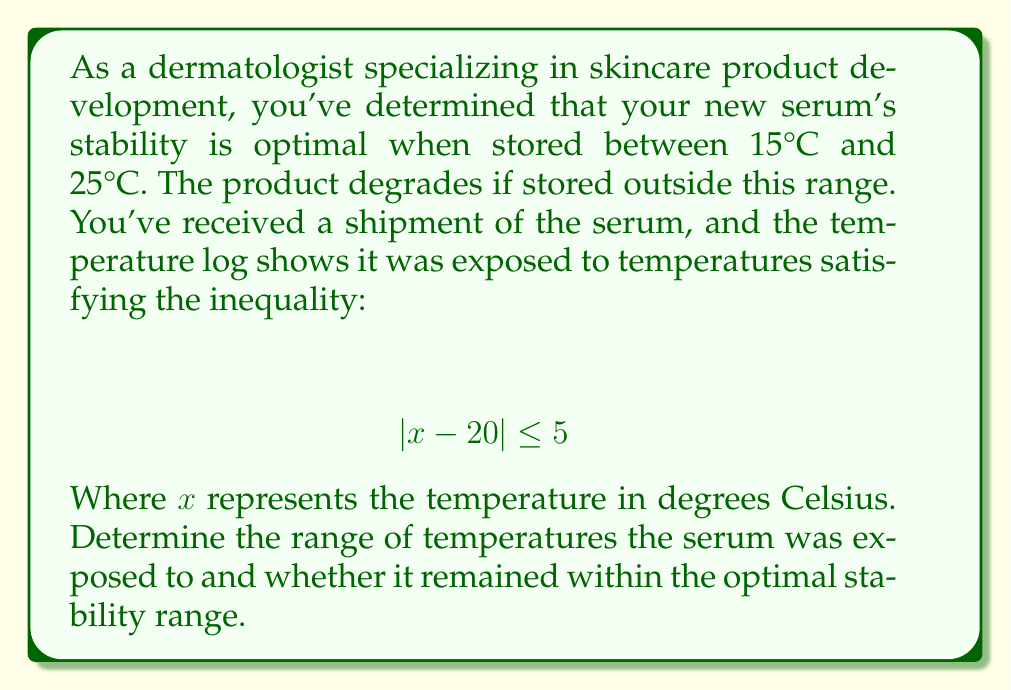Can you solve this math problem? Let's approach this step-by-step:

1) The inequality $|x - 20| \leq 5$ can be interpreted as the absolute difference between $x$ and 20 being less than or equal to 5.

2) To solve this, we can split it into two parts:
   $$ -5 \leq x - 20 \leq 5 $$

3) Add 20 to all parts of the inequality:
   $$ -5 + 20 \leq x - 20 + 20 \leq 5 + 20 $$
   $$ 15 \leq x \leq 25 $$

4) This means the serum was exposed to temperatures between 15°C and 25°C, inclusive.

5) Now, let's compare this to the optimal stability range (15°C to 25°C):
   - The lower bound (15°C) matches the optimal range's lower bound.
   - The upper bound (25°C) matches the optimal range's upper bound.

6) Therefore, the serum was exposed to temperatures exactly within the optimal stability range.
Answer: The serum was exposed to temperatures between 15°C and 25°C, which is precisely within the optimal stability range for the product. 